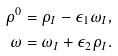<formula> <loc_0><loc_0><loc_500><loc_500>\rho ^ { 0 } & = \rho _ { I } - \epsilon _ { 1 } \omega _ { I } , \\ \omega & = \omega _ { I } + \epsilon _ { 2 } \rho _ { I } .</formula> 